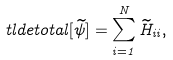Convert formula to latex. <formula><loc_0><loc_0><loc_500><loc_500>\ t l d e t o t a l [ \widetilde { \psi } ] = \sum _ { i = 1 } ^ { N } \widetilde { H } _ { i i } ,</formula> 